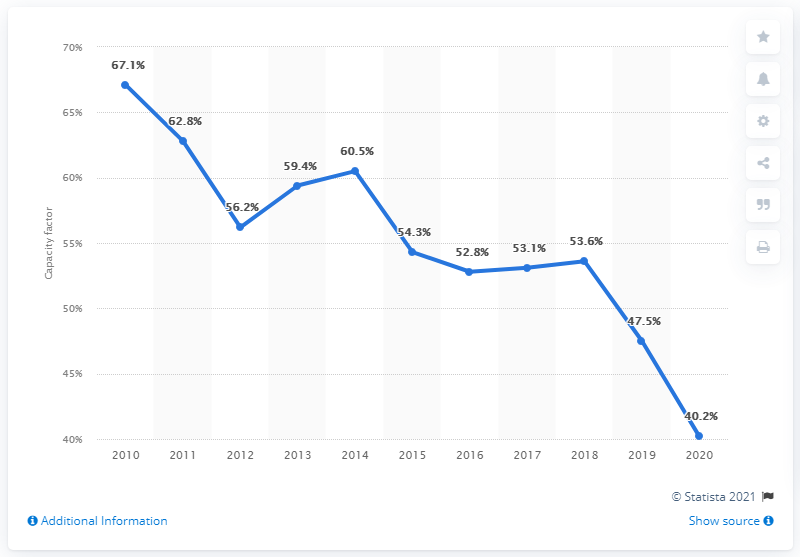Indicate a few pertinent items in this graphic. The average capacity factor of all coal plants in the United States in 2020 was 40.2%. 